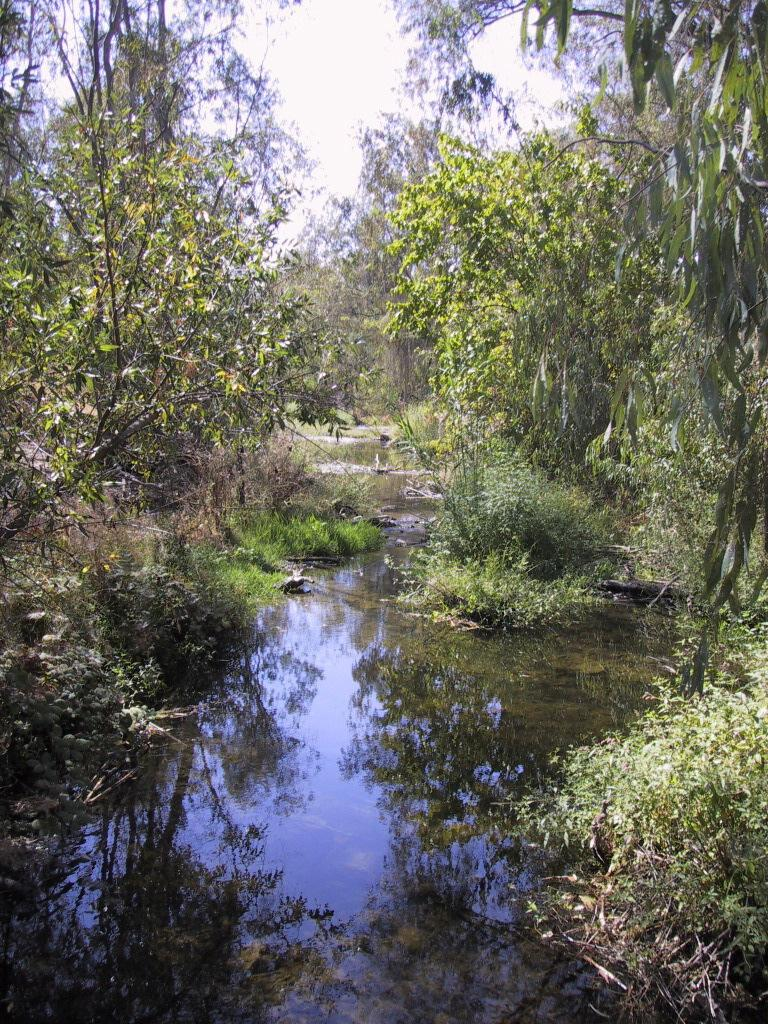What type of vegetation can be seen in the image? There are trees and plants visible in the image. What natural element is present in the image? There is water visible in the image. What part of the natural environment is visible in the background of the image? The sky is visible in the background of the image. What type of lace can be seen on the trees in the image? There is no lace present on the trees in the image; they are natural vegetation. 